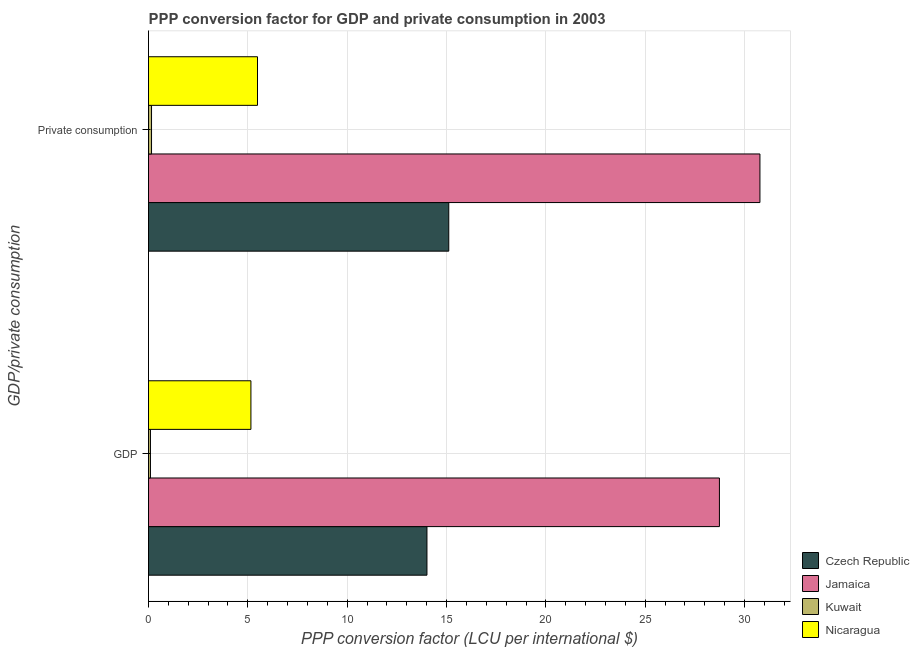How many different coloured bars are there?
Your answer should be compact. 4. Are the number of bars on each tick of the Y-axis equal?
Provide a succinct answer. Yes. How many bars are there on the 1st tick from the top?
Offer a very short reply. 4. How many bars are there on the 1st tick from the bottom?
Provide a short and direct response. 4. What is the label of the 1st group of bars from the top?
Make the answer very short.  Private consumption. What is the ppp conversion factor for private consumption in Kuwait?
Give a very brief answer. 0.15. Across all countries, what is the maximum ppp conversion factor for gdp?
Ensure brevity in your answer.  28.74. Across all countries, what is the minimum ppp conversion factor for private consumption?
Offer a terse response. 0.15. In which country was the ppp conversion factor for gdp maximum?
Provide a short and direct response. Jamaica. In which country was the ppp conversion factor for gdp minimum?
Provide a short and direct response. Kuwait. What is the total ppp conversion factor for private consumption in the graph?
Provide a succinct answer. 51.52. What is the difference between the ppp conversion factor for gdp in Jamaica and that in Kuwait?
Your answer should be very brief. 28.64. What is the difference between the ppp conversion factor for private consumption in Jamaica and the ppp conversion factor for gdp in Kuwait?
Give a very brief answer. 30.68. What is the average ppp conversion factor for private consumption per country?
Your answer should be compact. 12.88. What is the difference between the ppp conversion factor for gdp and ppp conversion factor for private consumption in Czech Republic?
Ensure brevity in your answer.  -1.1. What is the ratio of the ppp conversion factor for gdp in Nicaragua to that in Czech Republic?
Give a very brief answer. 0.37. In how many countries, is the ppp conversion factor for private consumption greater than the average ppp conversion factor for private consumption taken over all countries?
Your response must be concise. 2. What does the 1st bar from the top in  Private consumption represents?
Your answer should be compact. Nicaragua. What does the 2nd bar from the bottom in  Private consumption represents?
Your answer should be compact. Jamaica. What is the difference between two consecutive major ticks on the X-axis?
Provide a short and direct response. 5. Are the values on the major ticks of X-axis written in scientific E-notation?
Keep it short and to the point. No. Does the graph contain grids?
Offer a terse response. Yes. How many legend labels are there?
Ensure brevity in your answer.  4. How are the legend labels stacked?
Provide a short and direct response. Vertical. What is the title of the graph?
Ensure brevity in your answer.  PPP conversion factor for GDP and private consumption in 2003. Does "Iraq" appear as one of the legend labels in the graph?
Your answer should be very brief. No. What is the label or title of the X-axis?
Offer a terse response. PPP conversion factor (LCU per international $). What is the label or title of the Y-axis?
Keep it short and to the point. GDP/private consumption. What is the PPP conversion factor (LCU per international $) in Czech Republic in GDP?
Provide a short and direct response. 14.01. What is the PPP conversion factor (LCU per international $) of Jamaica in GDP?
Your answer should be compact. 28.74. What is the PPP conversion factor (LCU per international $) in Kuwait in GDP?
Offer a terse response. 0.1. What is the PPP conversion factor (LCU per international $) in Nicaragua in GDP?
Offer a very short reply. 5.15. What is the PPP conversion factor (LCU per international $) of Czech Republic in  Private consumption?
Offer a terse response. 15.11. What is the PPP conversion factor (LCU per international $) of Jamaica in  Private consumption?
Provide a succinct answer. 30.77. What is the PPP conversion factor (LCU per international $) in Kuwait in  Private consumption?
Provide a short and direct response. 0.15. What is the PPP conversion factor (LCU per international $) of Nicaragua in  Private consumption?
Make the answer very short. 5.49. Across all GDP/private consumption, what is the maximum PPP conversion factor (LCU per international $) in Czech Republic?
Provide a succinct answer. 15.11. Across all GDP/private consumption, what is the maximum PPP conversion factor (LCU per international $) in Jamaica?
Provide a succinct answer. 30.77. Across all GDP/private consumption, what is the maximum PPP conversion factor (LCU per international $) in Kuwait?
Provide a succinct answer. 0.15. Across all GDP/private consumption, what is the maximum PPP conversion factor (LCU per international $) in Nicaragua?
Your answer should be compact. 5.49. Across all GDP/private consumption, what is the minimum PPP conversion factor (LCU per international $) in Czech Republic?
Your answer should be compact. 14.01. Across all GDP/private consumption, what is the minimum PPP conversion factor (LCU per international $) of Jamaica?
Offer a terse response. 28.74. Across all GDP/private consumption, what is the minimum PPP conversion factor (LCU per international $) of Kuwait?
Offer a terse response. 0.1. Across all GDP/private consumption, what is the minimum PPP conversion factor (LCU per international $) of Nicaragua?
Make the answer very short. 5.15. What is the total PPP conversion factor (LCU per international $) of Czech Republic in the graph?
Offer a very short reply. 29.13. What is the total PPP conversion factor (LCU per international $) in Jamaica in the graph?
Offer a terse response. 59.51. What is the total PPP conversion factor (LCU per international $) of Kuwait in the graph?
Provide a succinct answer. 0.25. What is the total PPP conversion factor (LCU per international $) in Nicaragua in the graph?
Give a very brief answer. 10.64. What is the difference between the PPP conversion factor (LCU per international $) of Czech Republic in GDP and that in  Private consumption?
Provide a succinct answer. -1.1. What is the difference between the PPP conversion factor (LCU per international $) of Jamaica in GDP and that in  Private consumption?
Your answer should be very brief. -2.04. What is the difference between the PPP conversion factor (LCU per international $) of Kuwait in GDP and that in  Private consumption?
Offer a terse response. -0.05. What is the difference between the PPP conversion factor (LCU per international $) in Nicaragua in GDP and that in  Private consumption?
Your answer should be compact. -0.33. What is the difference between the PPP conversion factor (LCU per international $) in Czech Republic in GDP and the PPP conversion factor (LCU per international $) in Jamaica in  Private consumption?
Ensure brevity in your answer.  -16.76. What is the difference between the PPP conversion factor (LCU per international $) in Czech Republic in GDP and the PPP conversion factor (LCU per international $) in Kuwait in  Private consumption?
Your response must be concise. 13.86. What is the difference between the PPP conversion factor (LCU per international $) in Czech Republic in GDP and the PPP conversion factor (LCU per international $) in Nicaragua in  Private consumption?
Provide a short and direct response. 8.53. What is the difference between the PPP conversion factor (LCU per international $) of Jamaica in GDP and the PPP conversion factor (LCU per international $) of Kuwait in  Private consumption?
Offer a very short reply. 28.58. What is the difference between the PPP conversion factor (LCU per international $) in Jamaica in GDP and the PPP conversion factor (LCU per international $) in Nicaragua in  Private consumption?
Keep it short and to the point. 23.25. What is the difference between the PPP conversion factor (LCU per international $) of Kuwait in GDP and the PPP conversion factor (LCU per international $) of Nicaragua in  Private consumption?
Give a very brief answer. -5.39. What is the average PPP conversion factor (LCU per international $) in Czech Republic per GDP/private consumption?
Provide a succinct answer. 14.56. What is the average PPP conversion factor (LCU per international $) of Jamaica per GDP/private consumption?
Keep it short and to the point. 29.76. What is the average PPP conversion factor (LCU per international $) of Kuwait per GDP/private consumption?
Offer a very short reply. 0.12. What is the average PPP conversion factor (LCU per international $) of Nicaragua per GDP/private consumption?
Provide a short and direct response. 5.32. What is the difference between the PPP conversion factor (LCU per international $) of Czech Republic and PPP conversion factor (LCU per international $) of Jamaica in GDP?
Provide a succinct answer. -14.72. What is the difference between the PPP conversion factor (LCU per international $) of Czech Republic and PPP conversion factor (LCU per international $) of Kuwait in GDP?
Offer a very short reply. 13.92. What is the difference between the PPP conversion factor (LCU per international $) of Czech Republic and PPP conversion factor (LCU per international $) of Nicaragua in GDP?
Keep it short and to the point. 8.86. What is the difference between the PPP conversion factor (LCU per international $) of Jamaica and PPP conversion factor (LCU per international $) of Kuwait in GDP?
Make the answer very short. 28.64. What is the difference between the PPP conversion factor (LCU per international $) in Jamaica and PPP conversion factor (LCU per international $) in Nicaragua in GDP?
Your answer should be compact. 23.58. What is the difference between the PPP conversion factor (LCU per international $) in Kuwait and PPP conversion factor (LCU per international $) in Nicaragua in GDP?
Offer a very short reply. -5.06. What is the difference between the PPP conversion factor (LCU per international $) of Czech Republic and PPP conversion factor (LCU per international $) of Jamaica in  Private consumption?
Your answer should be very brief. -15.66. What is the difference between the PPP conversion factor (LCU per international $) of Czech Republic and PPP conversion factor (LCU per international $) of Kuwait in  Private consumption?
Ensure brevity in your answer.  14.96. What is the difference between the PPP conversion factor (LCU per international $) of Czech Republic and PPP conversion factor (LCU per international $) of Nicaragua in  Private consumption?
Offer a very short reply. 9.63. What is the difference between the PPP conversion factor (LCU per international $) of Jamaica and PPP conversion factor (LCU per international $) of Kuwait in  Private consumption?
Keep it short and to the point. 30.62. What is the difference between the PPP conversion factor (LCU per international $) in Jamaica and PPP conversion factor (LCU per international $) in Nicaragua in  Private consumption?
Your response must be concise. 25.29. What is the difference between the PPP conversion factor (LCU per international $) of Kuwait and PPP conversion factor (LCU per international $) of Nicaragua in  Private consumption?
Provide a succinct answer. -5.33. What is the ratio of the PPP conversion factor (LCU per international $) of Czech Republic in GDP to that in  Private consumption?
Provide a short and direct response. 0.93. What is the ratio of the PPP conversion factor (LCU per international $) of Jamaica in GDP to that in  Private consumption?
Offer a terse response. 0.93. What is the ratio of the PPP conversion factor (LCU per international $) of Kuwait in GDP to that in  Private consumption?
Offer a terse response. 0.64. What is the ratio of the PPP conversion factor (LCU per international $) in Nicaragua in GDP to that in  Private consumption?
Your response must be concise. 0.94. What is the difference between the highest and the second highest PPP conversion factor (LCU per international $) of Czech Republic?
Offer a terse response. 1.1. What is the difference between the highest and the second highest PPP conversion factor (LCU per international $) in Jamaica?
Provide a succinct answer. 2.04. What is the difference between the highest and the second highest PPP conversion factor (LCU per international $) in Kuwait?
Provide a short and direct response. 0.05. What is the difference between the highest and the second highest PPP conversion factor (LCU per international $) of Nicaragua?
Ensure brevity in your answer.  0.33. What is the difference between the highest and the lowest PPP conversion factor (LCU per international $) in Czech Republic?
Offer a terse response. 1.1. What is the difference between the highest and the lowest PPP conversion factor (LCU per international $) of Jamaica?
Give a very brief answer. 2.04. What is the difference between the highest and the lowest PPP conversion factor (LCU per international $) in Kuwait?
Offer a terse response. 0.05. What is the difference between the highest and the lowest PPP conversion factor (LCU per international $) of Nicaragua?
Your answer should be compact. 0.33. 